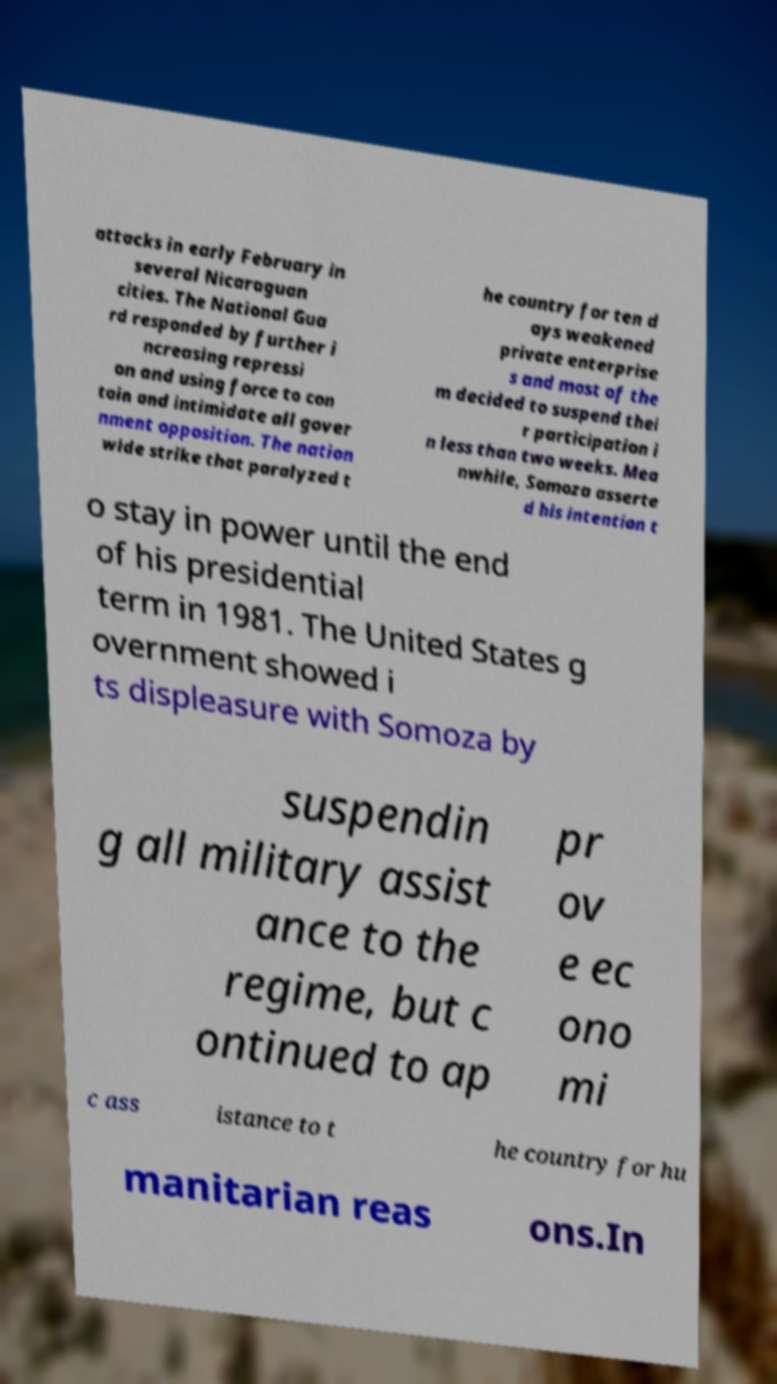Could you extract and type out the text from this image? attacks in early February in several Nicaraguan cities. The National Gua rd responded by further i ncreasing repressi on and using force to con tain and intimidate all gover nment opposition. The nation wide strike that paralyzed t he country for ten d ays weakened private enterprise s and most of the m decided to suspend thei r participation i n less than two weeks. Mea nwhile, Somoza asserte d his intention t o stay in power until the end of his presidential term in 1981. The United States g overnment showed i ts displeasure with Somoza by suspendin g all military assist ance to the regime, but c ontinued to ap pr ov e ec ono mi c ass istance to t he country for hu manitarian reas ons.In 